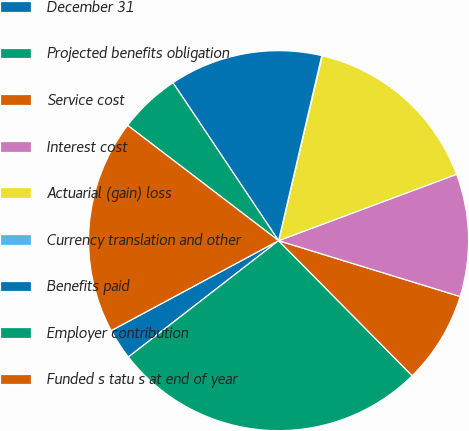<chart> <loc_0><loc_0><loc_500><loc_500><pie_chart><fcel>December 31<fcel>Projected benefits obligation<fcel>Service cost<fcel>Interest cost<fcel>Actuarial (gain) loss<fcel>Currency translation and other<fcel>Benefits paid<fcel>Employer contribution<fcel>Funded s tatu s at end of year<nl><fcel>2.64%<fcel>26.92%<fcel>7.84%<fcel>10.43%<fcel>15.63%<fcel>0.04%<fcel>13.03%<fcel>5.24%<fcel>18.23%<nl></chart> 